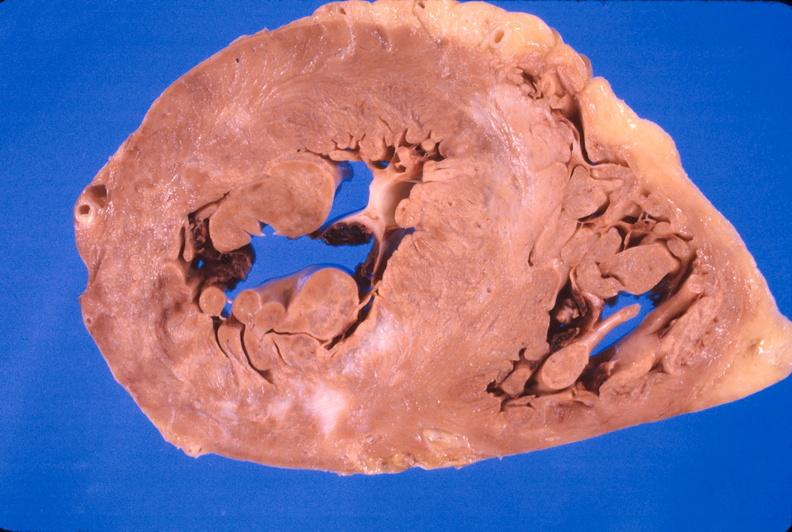what is present?
Answer the question using a single word or phrase. Cardiovascular 